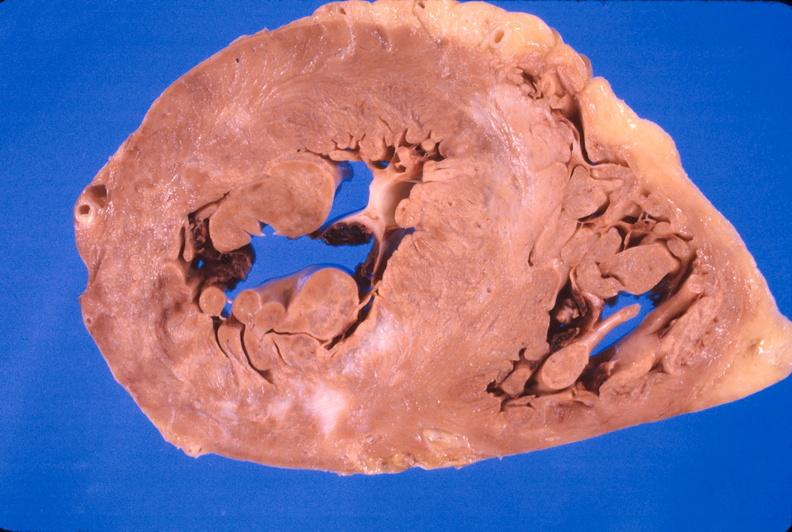what is present?
Answer the question using a single word or phrase. Cardiovascular 